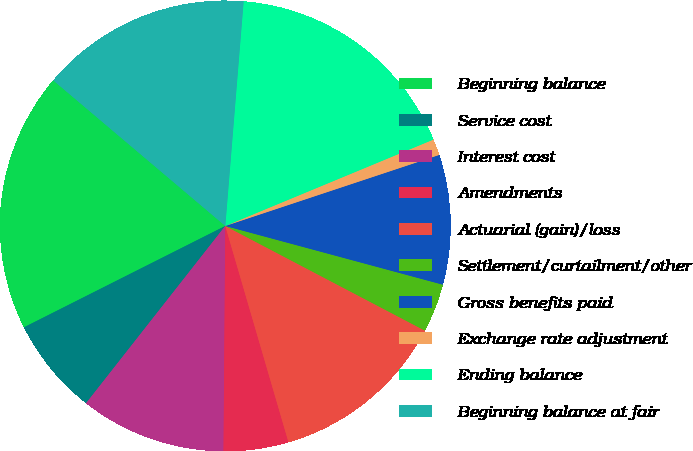Convert chart. <chart><loc_0><loc_0><loc_500><loc_500><pie_chart><fcel>Beginning balance<fcel>Service cost<fcel>Interest cost<fcel>Amendments<fcel>Actuarial (gain)/loss<fcel>Settlement/curtailment/other<fcel>Gross benefits paid<fcel>Exchange rate adjustment<fcel>Ending balance<fcel>Beginning balance at fair<nl><fcel>18.6%<fcel>6.98%<fcel>10.47%<fcel>4.65%<fcel>12.79%<fcel>3.49%<fcel>9.3%<fcel>1.16%<fcel>17.44%<fcel>15.12%<nl></chart> 